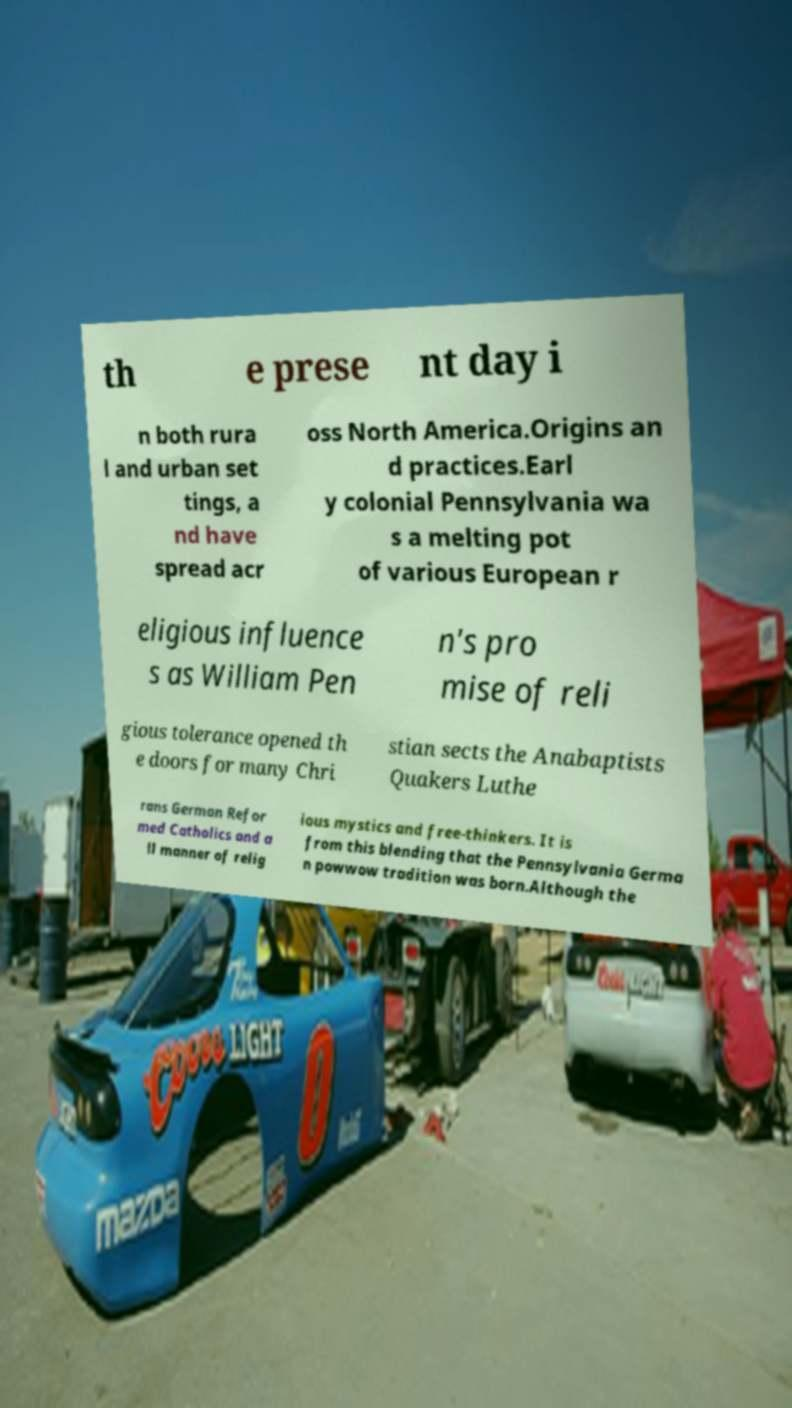Please read and relay the text visible in this image. What does it say? th e prese nt day i n both rura l and urban set tings, a nd have spread acr oss North America.Origins an d practices.Earl y colonial Pennsylvania wa s a melting pot of various European r eligious influence s as William Pen n's pro mise of reli gious tolerance opened th e doors for many Chri stian sects the Anabaptists Quakers Luthe rans German Refor med Catholics and a ll manner of relig ious mystics and free-thinkers. It is from this blending that the Pennsylvania Germa n powwow tradition was born.Although the 